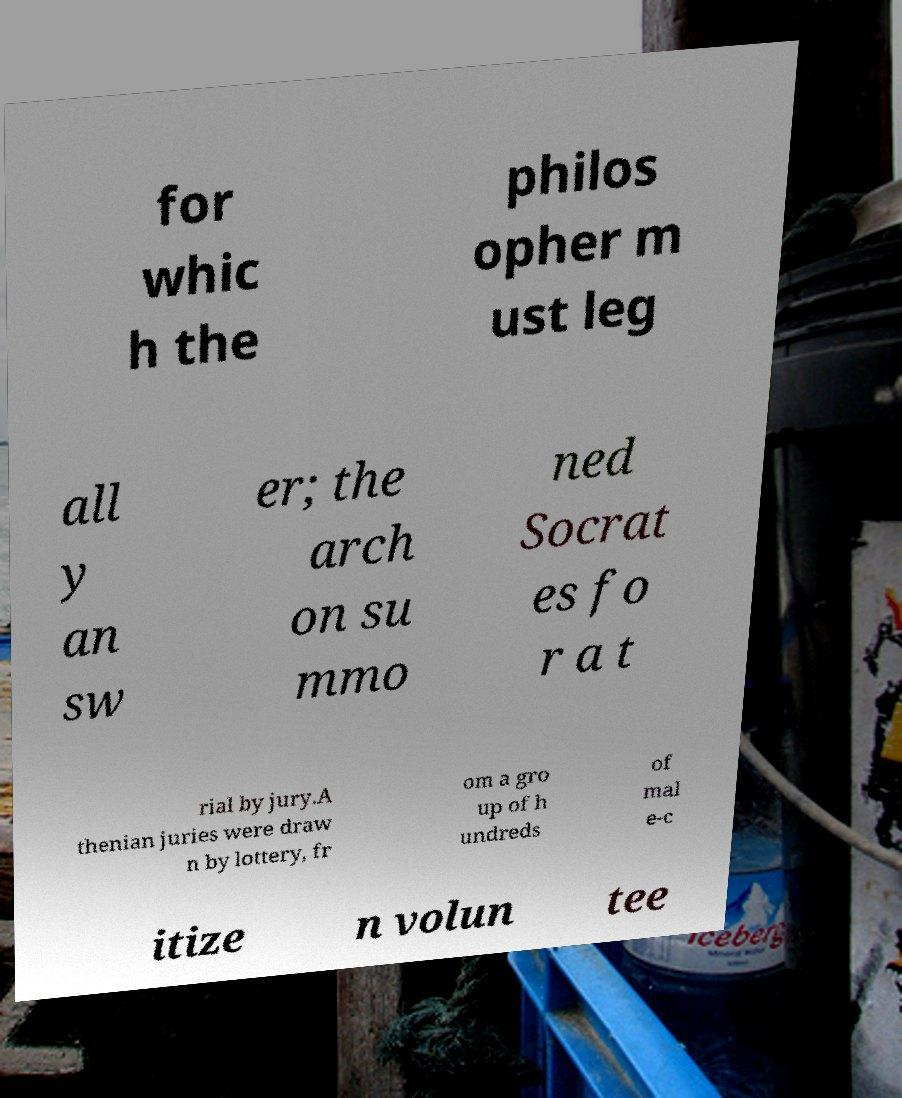Can you accurately transcribe the text from the provided image for me? for whic h the philos opher m ust leg all y an sw er; the arch on su mmo ned Socrat es fo r a t rial by jury.A thenian juries were draw n by lottery, fr om a gro up of h undreds of mal e-c itize n volun tee 